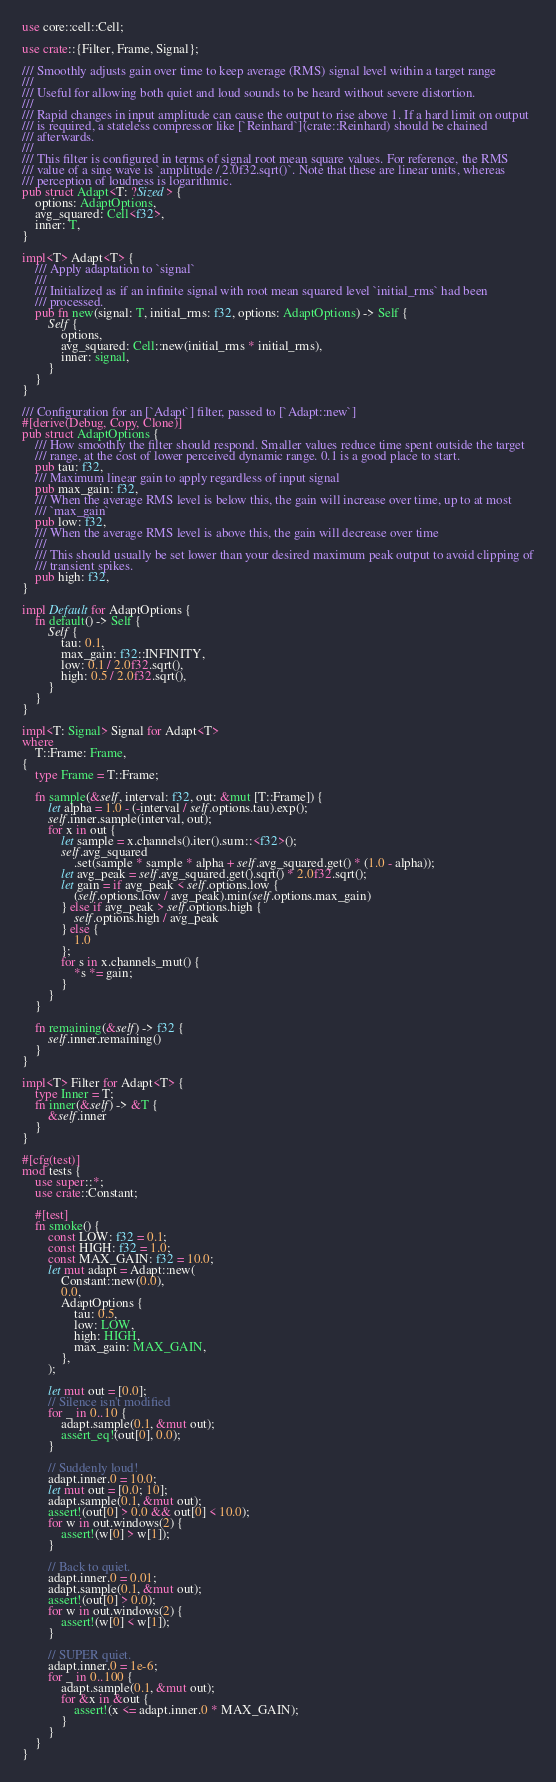<code> <loc_0><loc_0><loc_500><loc_500><_Rust_>use core::cell::Cell;

use crate::{Filter, Frame, Signal};

/// Smoothly adjusts gain over time to keep average (RMS) signal level within a target range
///
/// Useful for allowing both quiet and loud sounds to be heard without severe distortion.
///
/// Rapid changes in input amplitude can cause the output to rise above 1. If a hard limit on output
/// is required, a stateless compressor like [`Reinhard`](crate::Reinhard) should be chained
/// afterwards.
///
/// This filter is configured in terms of signal root mean square values. For reference, the RMS
/// value of a sine wave is `amplitude / 2.0f32.sqrt()`. Note that these are linear units, whereas
/// perception of loudness is logarithmic.
pub struct Adapt<T: ?Sized> {
    options: AdaptOptions,
    avg_squared: Cell<f32>,
    inner: T,
}

impl<T> Adapt<T> {
    /// Apply adaptation to `signal`
    ///
    /// Initialized as if an infinite signal with root mean squared level `initial_rms` had been
    /// processed.
    pub fn new(signal: T, initial_rms: f32, options: AdaptOptions) -> Self {
        Self {
            options,
            avg_squared: Cell::new(initial_rms * initial_rms),
            inner: signal,
        }
    }
}

/// Configuration for an [`Adapt`] filter, passed to [`Adapt::new`]
#[derive(Debug, Copy, Clone)]
pub struct AdaptOptions {
    /// How smoothly the filter should respond. Smaller values reduce time spent outside the target
    /// range, at the cost of lower perceived dynamic range. 0.1 is a good place to start.
    pub tau: f32,
    /// Maximum linear gain to apply regardless of input signal
    pub max_gain: f32,
    /// When the average RMS level is below this, the gain will increase over time, up to at most
    /// `max_gain`
    pub low: f32,
    /// When the average RMS level is above this, the gain will decrease over time
    ///
    /// This should usually be set lower than your desired maximum peak output to avoid clipping of
    /// transient spikes.
    pub high: f32,
}

impl Default for AdaptOptions {
    fn default() -> Self {
        Self {
            tau: 0.1,
            max_gain: f32::INFINITY,
            low: 0.1 / 2.0f32.sqrt(),
            high: 0.5 / 2.0f32.sqrt(),
        }
    }
}

impl<T: Signal> Signal for Adapt<T>
where
    T::Frame: Frame,
{
    type Frame = T::Frame;

    fn sample(&self, interval: f32, out: &mut [T::Frame]) {
        let alpha = 1.0 - (-interval / self.options.tau).exp();
        self.inner.sample(interval, out);
        for x in out {
            let sample = x.channels().iter().sum::<f32>();
            self.avg_squared
                .set(sample * sample * alpha + self.avg_squared.get() * (1.0 - alpha));
            let avg_peak = self.avg_squared.get().sqrt() * 2.0f32.sqrt();
            let gain = if avg_peak < self.options.low {
                (self.options.low / avg_peak).min(self.options.max_gain)
            } else if avg_peak > self.options.high {
                self.options.high / avg_peak
            } else {
                1.0
            };
            for s in x.channels_mut() {
                *s *= gain;
            }
        }
    }

    fn remaining(&self) -> f32 {
        self.inner.remaining()
    }
}

impl<T> Filter for Adapt<T> {
    type Inner = T;
    fn inner(&self) -> &T {
        &self.inner
    }
}

#[cfg(test)]
mod tests {
    use super::*;
    use crate::Constant;

    #[test]
    fn smoke() {
        const LOW: f32 = 0.1;
        const HIGH: f32 = 1.0;
        const MAX_GAIN: f32 = 10.0;
        let mut adapt = Adapt::new(
            Constant::new(0.0),
            0.0,
            AdaptOptions {
                tau: 0.5,
                low: LOW,
                high: HIGH,
                max_gain: MAX_GAIN,
            },
        );

        let mut out = [0.0];
        // Silence isn't modified
        for _ in 0..10 {
            adapt.sample(0.1, &mut out);
            assert_eq!(out[0], 0.0);
        }

        // Suddenly loud!
        adapt.inner.0 = 10.0;
        let mut out = [0.0; 10];
        adapt.sample(0.1, &mut out);
        assert!(out[0] > 0.0 && out[0] < 10.0);
        for w in out.windows(2) {
            assert!(w[0] > w[1]);
        }

        // Back to quiet.
        adapt.inner.0 = 0.01;
        adapt.sample(0.1, &mut out);
        assert!(out[0] > 0.0);
        for w in out.windows(2) {
            assert!(w[0] < w[1]);
        }

        // SUPER quiet.
        adapt.inner.0 = 1e-6;
        for _ in 0..100 {
            adapt.sample(0.1, &mut out);
            for &x in &out {
                assert!(x <= adapt.inner.0 * MAX_GAIN);
            }
        }
    }
}
</code> 